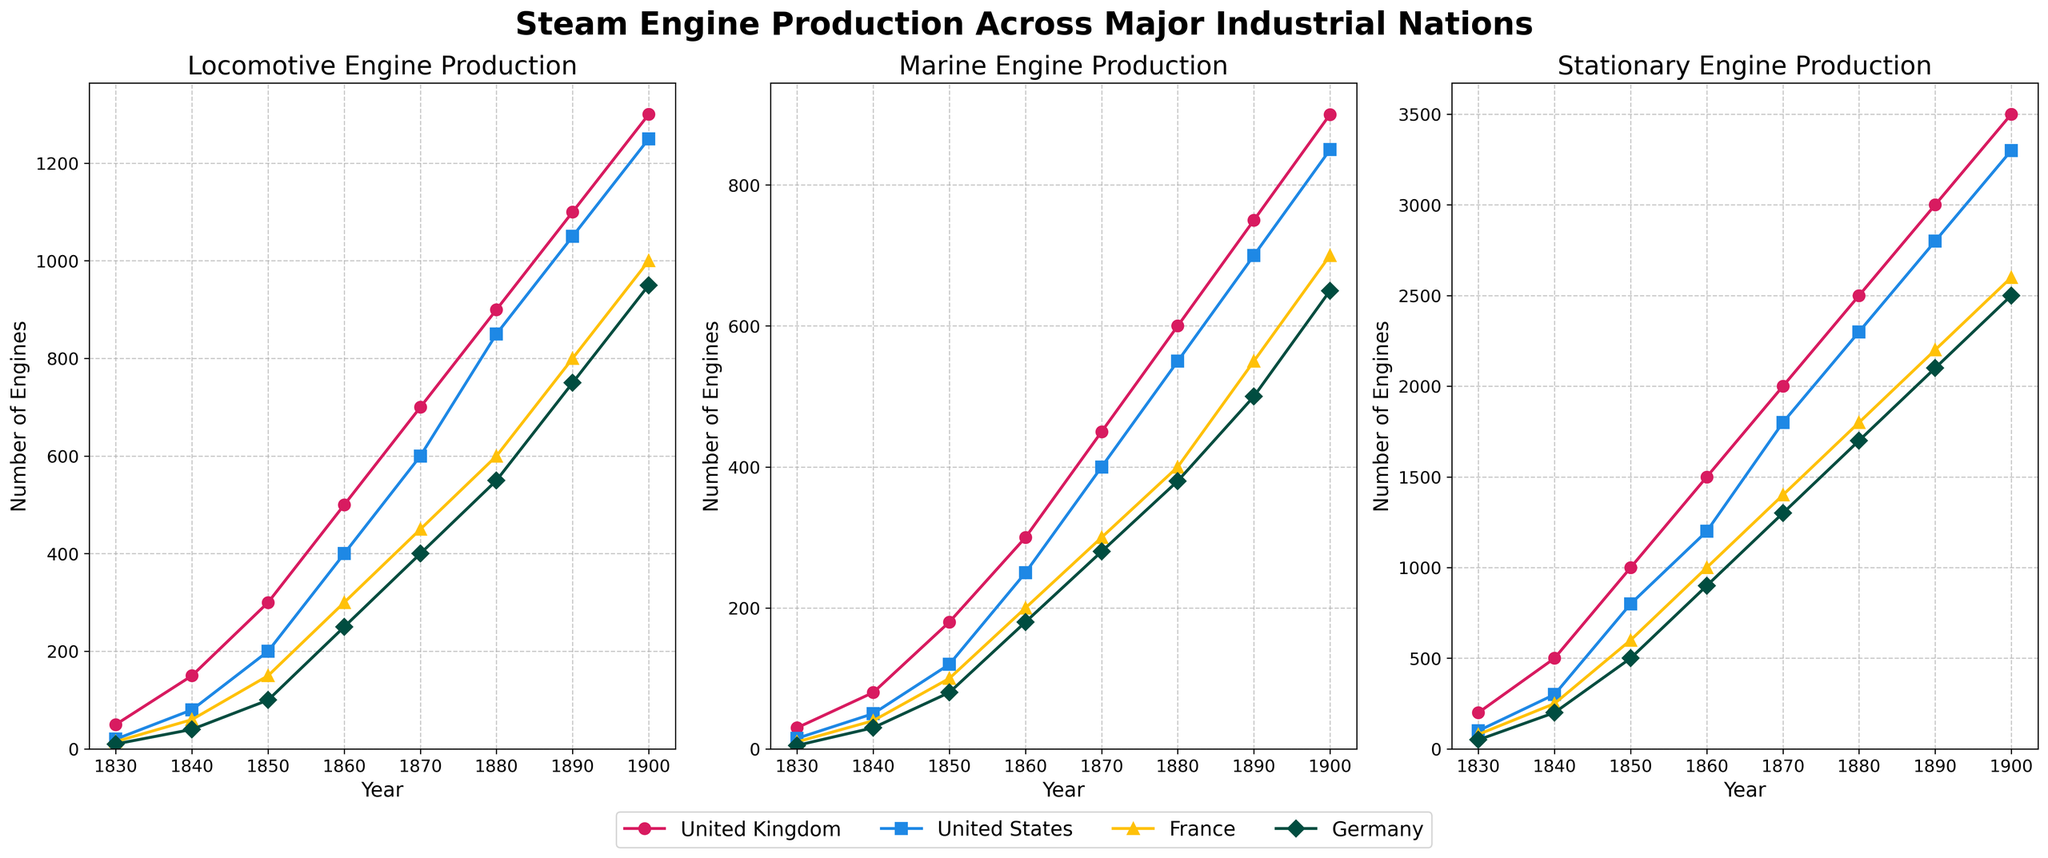Which country had the highest production of locomotive engines in 1880? By looking at the locomotive engine subplot, we can observe that in 1880, the purple line representing the United Kingdom is the highest among all countries.
Answer: United Kingdom What was the combined production of marine engines in the United Kingdom and France in 1860? Referring to the marine engine subplot, in 1860, the United Kingdom produced 300 marine engines, and France produced 200. Adding these values, we get 300 + 200 = 500.
Answer: 500 How did the production of stationary engines in Germany change from 1830 to 1900? In the stationary engine subplot, we see the green line representing Germany starting at 50 engines in 1830 and increasing to 2500 engines in 1900. There is a steady increase over time.
Answer: Increased to 2500 Which year saw the greatest difference in locomotive engine production between the United States and France? Checking the locomotive engine subplot, observe the difference in production between the United States (blue) and France (green) for each year. The biggest difference is in 1900, where the United States produced 1250 engines and France produced 1000 engines, a difference of 250 engines.
Answer: 1900 Did marine engine production in the United States ever surpass that in the United Kingdom? By examining the marine engine subplot, we can see that the United States' (blue) production never surpassed the United Kingdom's (red) production in any year displayed.
Answer: No Which decade saw the largest increase in stationary engine production in the United Kingdom? In the stationary engine subplot, the United Kingdom's red line shows the most significant jump between 1840 and 1850, where production increased from 500 to 1000, an increase of 500 engines.
Answer: 1840-1850 What is the trend for marine engine production in France from 1830 to 1900? Looking at the marine engine subplot, the green line for France shows a continuous increase from 10 engines in 1830 to 700 engines in 1900.
Answer: Increase In 1870, which type of engine production had the highest count in the United Kingdom? Observing the 1870 markers for the United Kingdom (red) in all three subplots, the number for stationary engines is the highest at 2000, compared to 700 for locomotives and 450 for marine engines.
Answer: Stationary Compare the locomotive engine production in 1840 between the United Kingdom and Germany. In the locomotive engine subplot for the year 1840, The United Kingdom produced 150 engines, and Germany produced 40 engines. The United Kingdom's production was much higher.
Answer: United Kingdom What was the average production of locomotive engines in the United States throughout the years listed? Summing up the United States' locomotive production values (20 + 80 + 200 + 400 + 600 + 850 + 1050 + 1250) and dividing by the number of years (8), we get (20 + 80 + 200 + 400 + 600 + 850 + 1050 + 1250) / 8 = 4450 / 8 = 556.25.
Answer: 556.25 